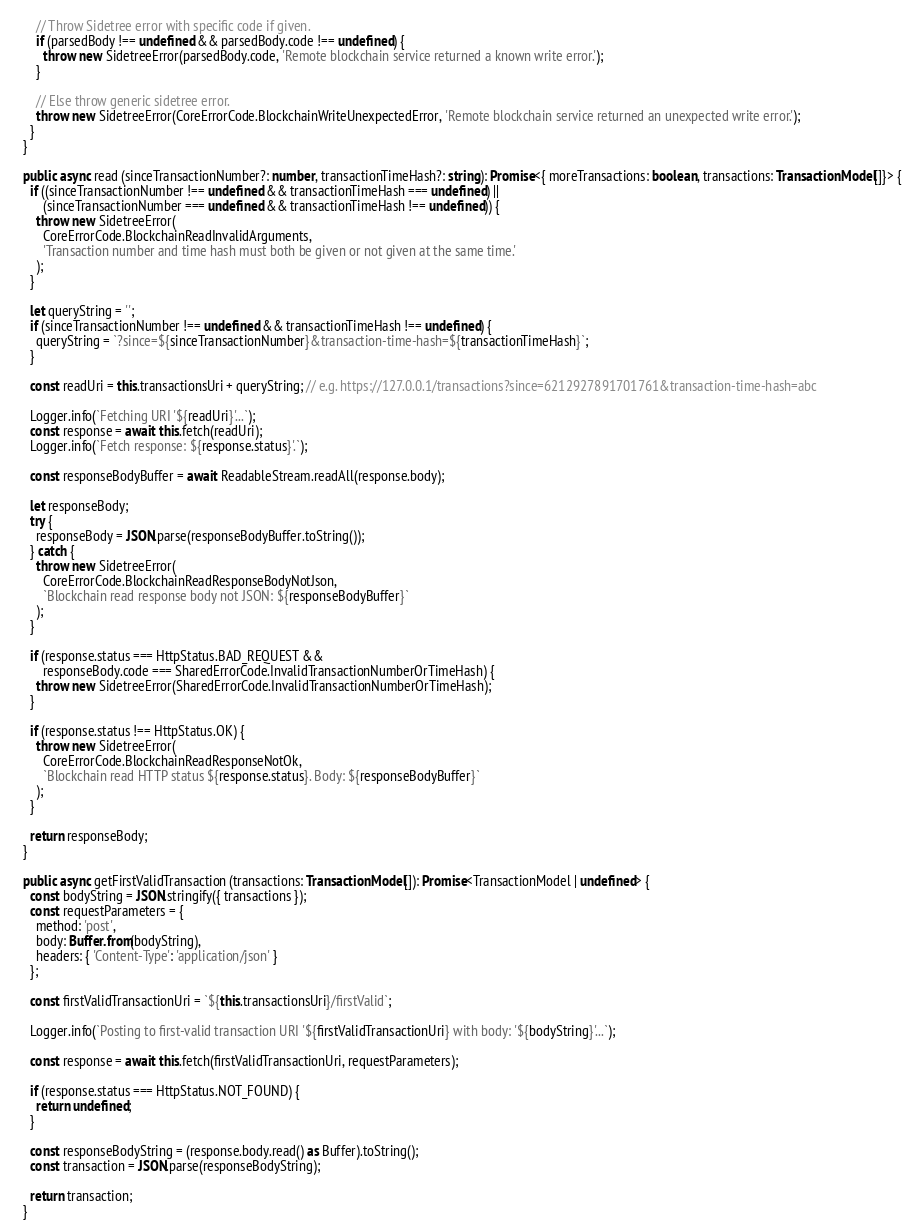Convert code to text. <code><loc_0><loc_0><loc_500><loc_500><_TypeScript_>
      // Throw Sidetree error with specific code if given.
      if (parsedBody !== undefined && parsedBody.code !== undefined) {
        throw new SidetreeError(parsedBody.code, 'Remote blockchain service returned a known write error.');
      }

      // Else throw generic sidetree error.
      throw new SidetreeError(CoreErrorCode.BlockchainWriteUnexpectedError, 'Remote blockchain service returned an unexpected write error.');
    }
  }

  public async read (sinceTransactionNumber?: number, transactionTimeHash?: string): Promise<{ moreTransactions: boolean, transactions: TransactionModel[]}> {
    if ((sinceTransactionNumber !== undefined && transactionTimeHash === undefined) ||
        (sinceTransactionNumber === undefined && transactionTimeHash !== undefined)) {
      throw new SidetreeError(
        CoreErrorCode.BlockchainReadInvalidArguments,
        'Transaction number and time hash must both be given or not given at the same time.'
      );
    }

    let queryString = '';
    if (sinceTransactionNumber !== undefined && transactionTimeHash !== undefined) {
      queryString = `?since=${sinceTransactionNumber}&transaction-time-hash=${transactionTimeHash}`;
    }

    const readUri = this.transactionsUri + queryString; // e.g. https://127.0.0.1/transactions?since=6212927891701761&transaction-time-hash=abc

    Logger.info(`Fetching URI '${readUri}'...`);
    const response = await this.fetch(readUri);
    Logger.info(`Fetch response: ${response.status}'.`);

    const responseBodyBuffer = await ReadableStream.readAll(response.body);

    let responseBody;
    try {
      responseBody = JSON.parse(responseBodyBuffer.toString());
    } catch {
      throw new SidetreeError(
        CoreErrorCode.BlockchainReadResponseBodyNotJson,
        `Blockchain read response body not JSON: ${responseBodyBuffer}`
      );
    }

    if (response.status === HttpStatus.BAD_REQUEST &&
        responseBody.code === SharedErrorCode.InvalidTransactionNumberOrTimeHash) {
      throw new SidetreeError(SharedErrorCode.InvalidTransactionNumberOrTimeHash);
    }

    if (response.status !== HttpStatus.OK) {
      throw new SidetreeError(
        CoreErrorCode.BlockchainReadResponseNotOk,
        `Blockchain read HTTP status ${response.status}. Body: ${responseBodyBuffer}`
      );
    }

    return responseBody;
  }

  public async getFirstValidTransaction (transactions: TransactionModel[]): Promise<TransactionModel | undefined> {
    const bodyString = JSON.stringify({ transactions });
    const requestParameters = {
      method: 'post',
      body: Buffer.from(bodyString),
      headers: { 'Content-Type': 'application/json' }
    };

    const firstValidTransactionUri = `${this.transactionsUri}/firstValid`;

    Logger.info(`Posting to first-valid transaction URI '${firstValidTransactionUri} with body: '${bodyString}'...`);

    const response = await this.fetch(firstValidTransactionUri, requestParameters);

    if (response.status === HttpStatus.NOT_FOUND) {
      return undefined;
    }

    const responseBodyString = (response.body.read() as Buffer).toString();
    const transaction = JSON.parse(responseBodyString);

    return transaction;
  }
</code> 